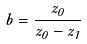Convert formula to latex. <formula><loc_0><loc_0><loc_500><loc_500>b = \frac { z _ { 0 } } { z _ { 0 } - z _ { 1 } }</formula> 